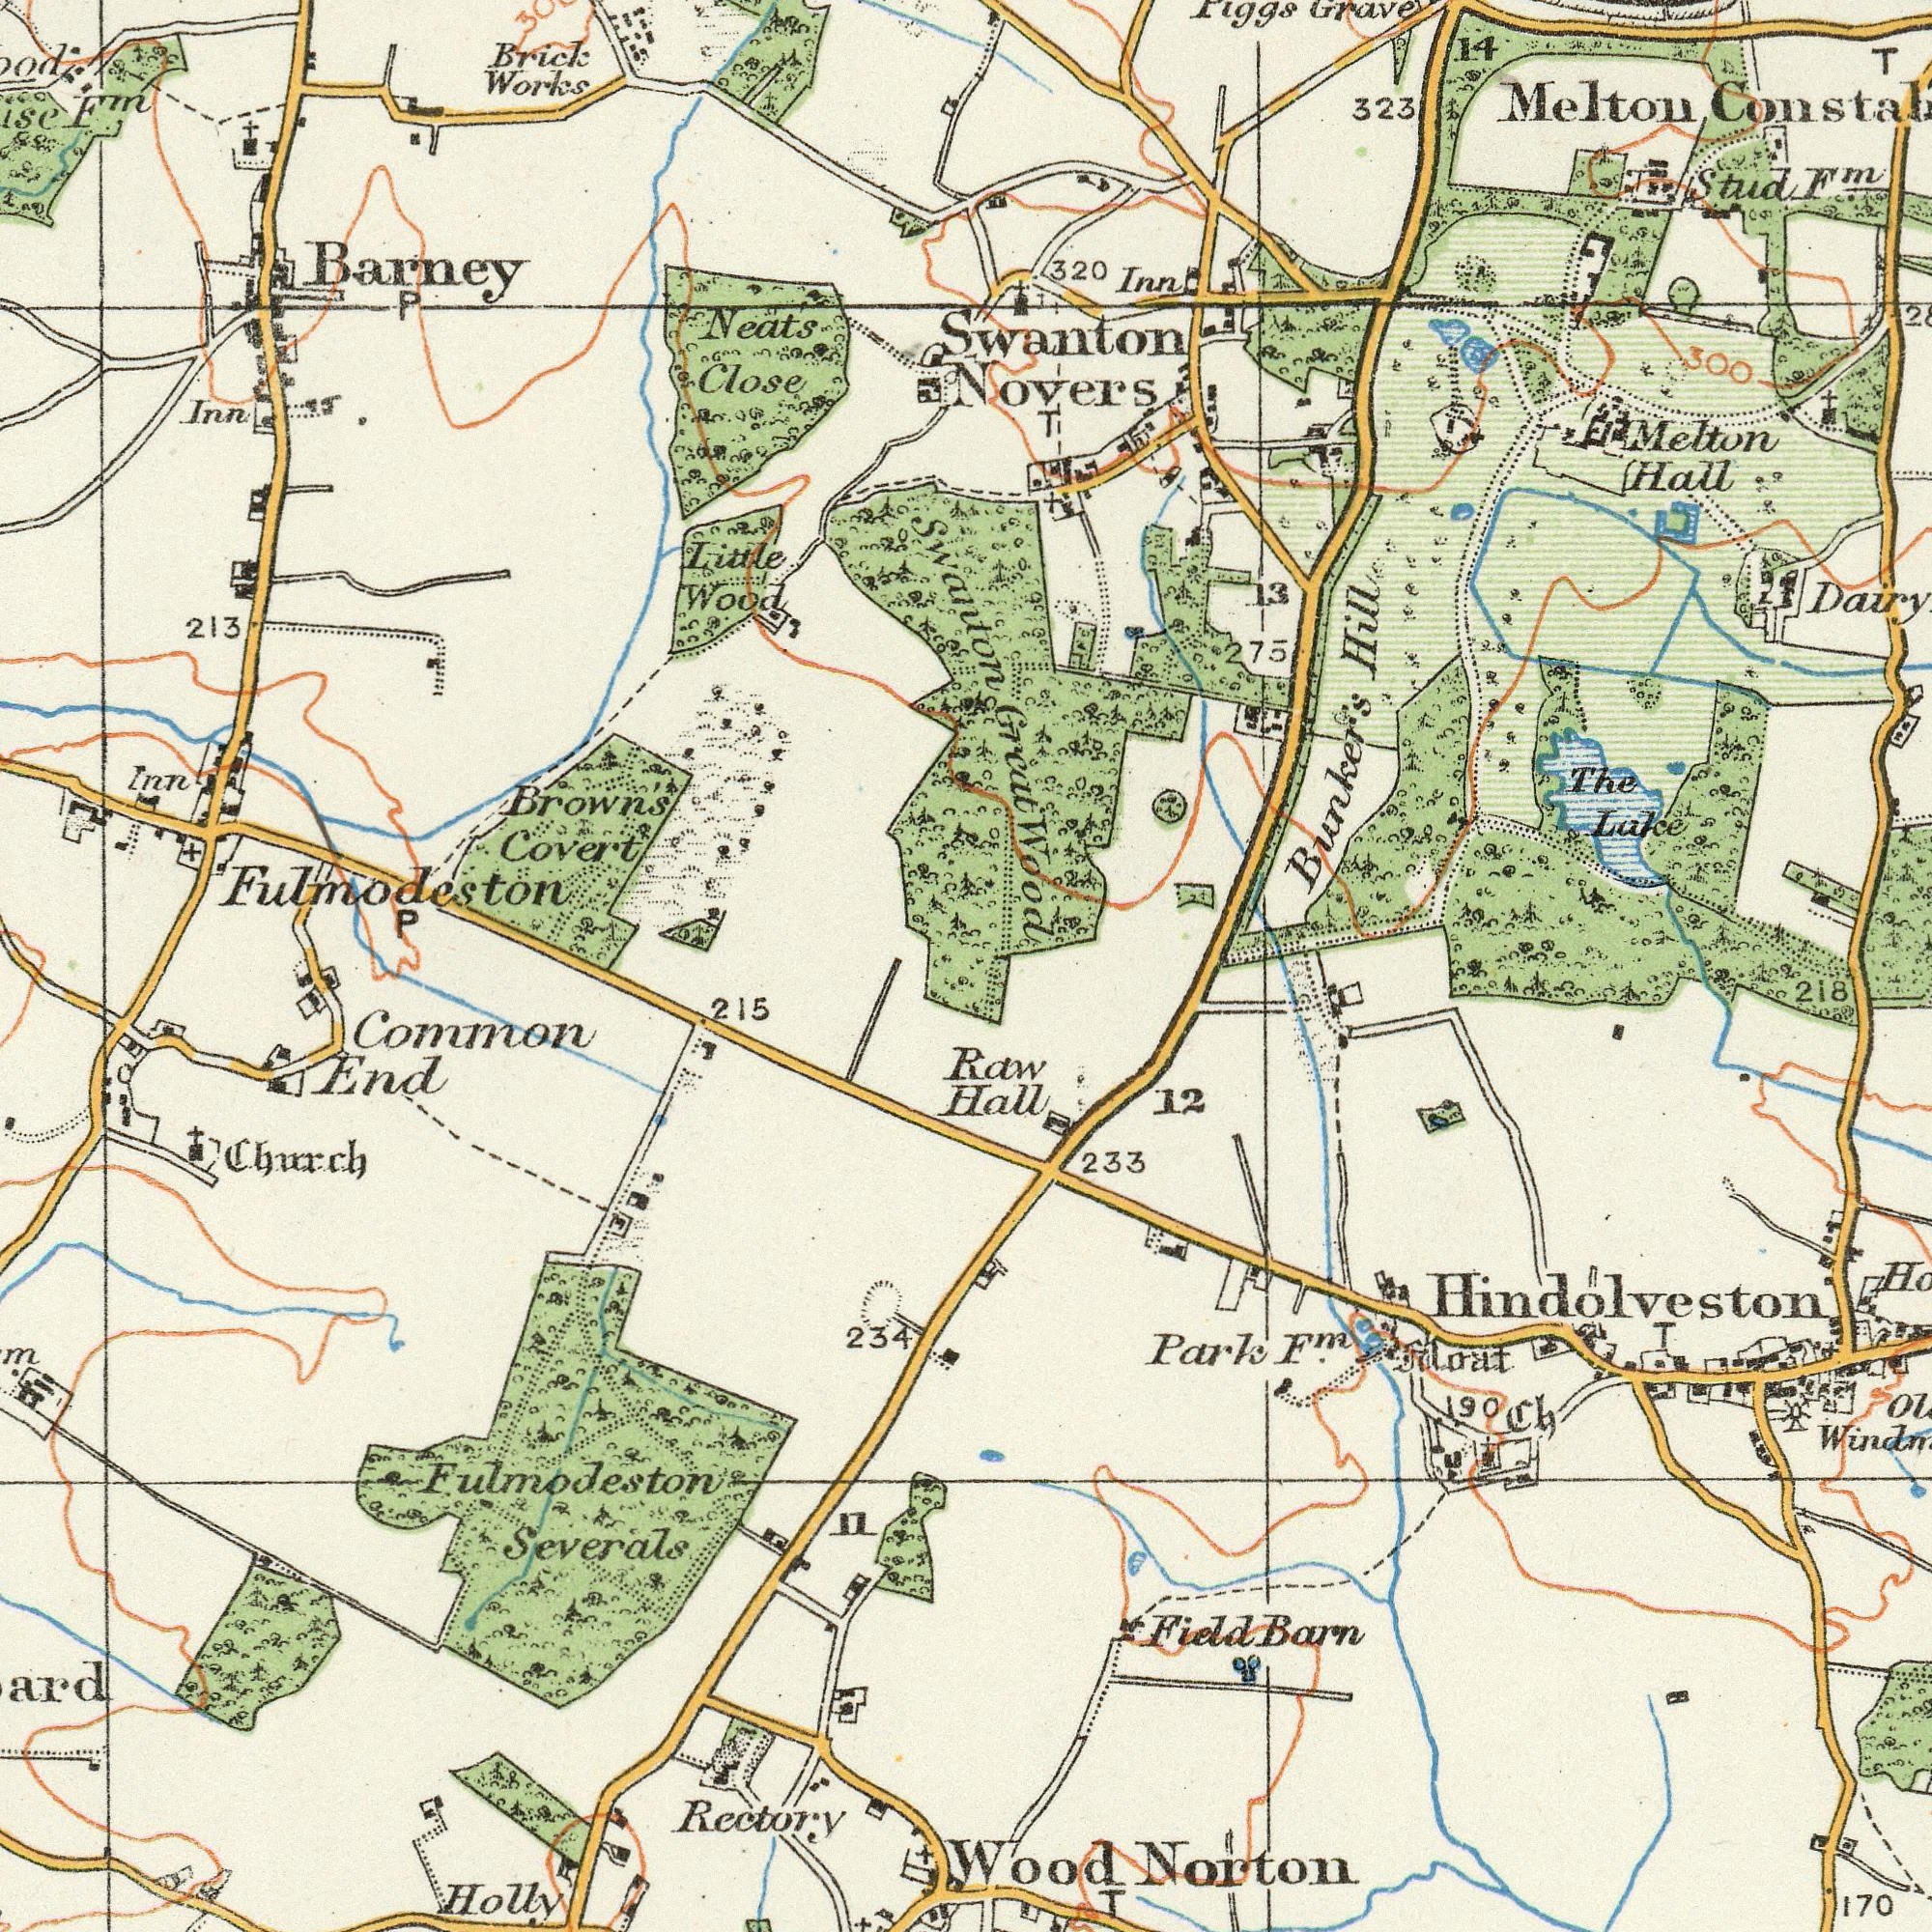What text is shown in the bottom-right quadrant? Wood Park Hall 170 12 233 Norton Moat T Ch 218 Barn Raw T Field 190 F<sup>m</sup>. Hindolveston What text appears in the top-left area of the image? Covert Works Brick Brown's Close Neats Inn Little Wood 213 Inn Barney Fulmodeston P F<sup>m</sup>. P Swanton What text can you see in the top-right section? Novers 320 323 Swanton Hall Lake The T Bunker's Inn Grave Stud MeIton Hill 14 13 Wood 300 F<sup>m</sup>. Melton T 275 Great What text can you see in the bottom-left section? Severals Holly End Common Rectory 215 234 Church Fulmodeston 